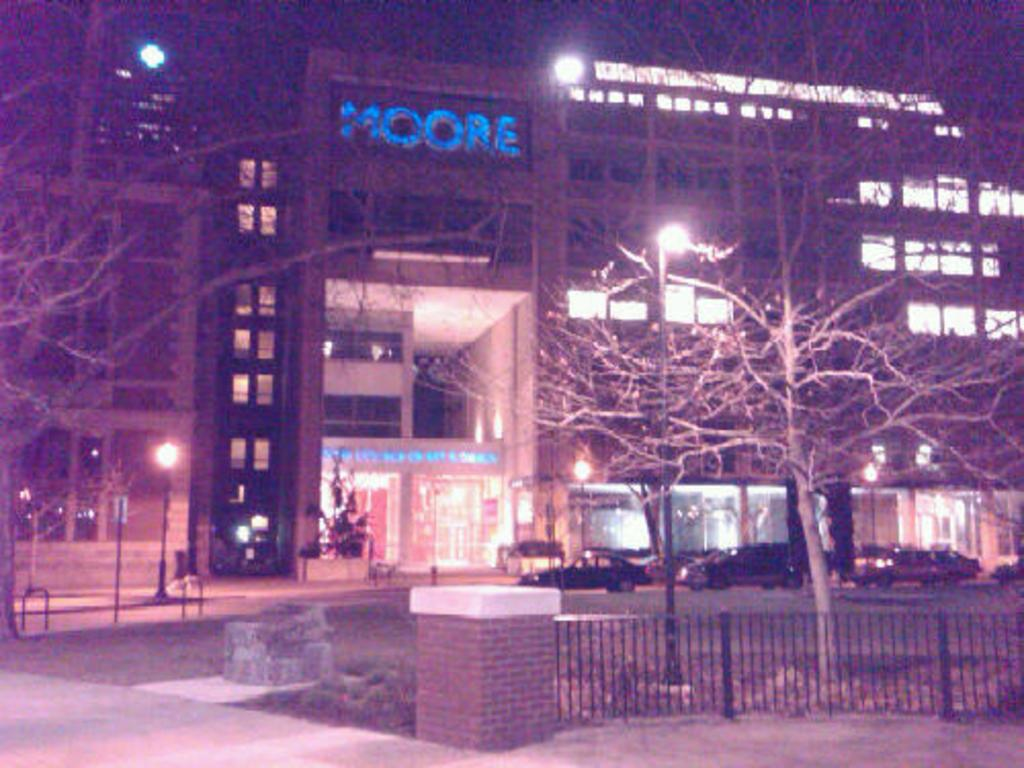What type of structure is depicted in the image? There is a building in the image, which resembles a hospital. Are there any vehicles present in the image? Yes, there are vehicles in front of the building. What else can be seen in front of the building? There are trees in front of the building. What type of barrier is visible in the image? There is a fencing in the image. Can you see a train passing by the hospital in the image? No, there is no train present in the image. How many ducks are visible near the trees in the image? There are no ducks visible in the image; only trees and vehicles are present. 